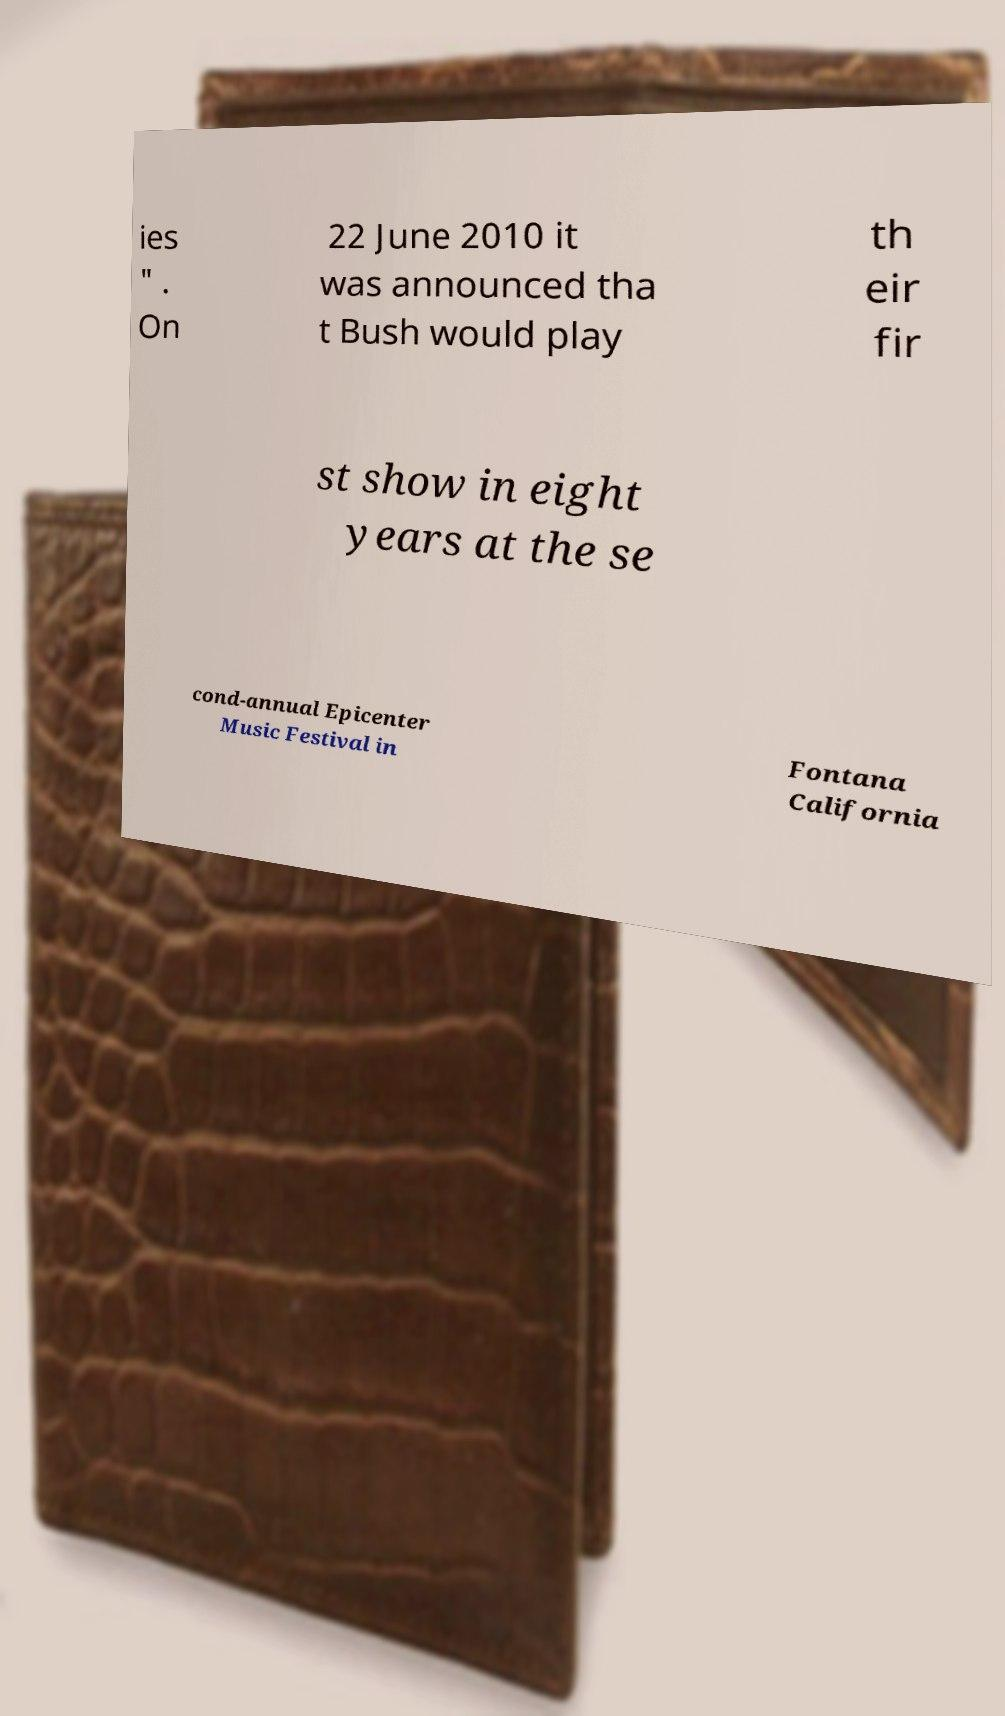Please read and relay the text visible in this image. What does it say? ies " . On 22 June 2010 it was announced tha t Bush would play th eir fir st show in eight years at the se cond-annual Epicenter Music Festival in Fontana California 